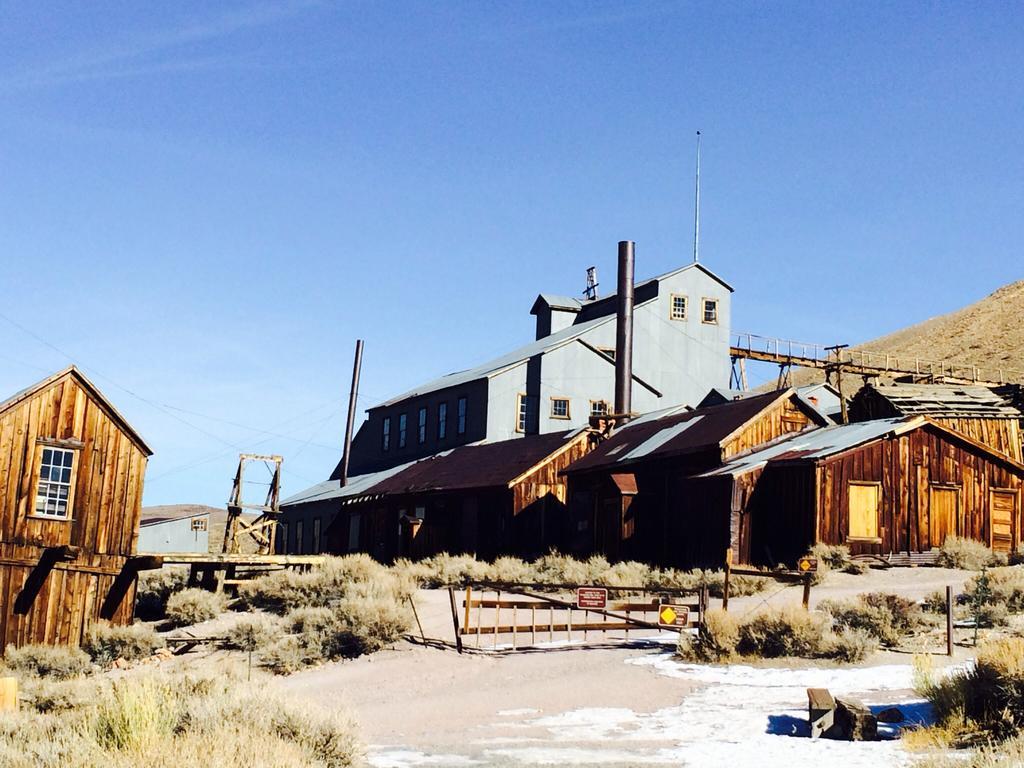Can you describe this image briefly? In this picture there are few wooden houses and there is a building behind it and the sky is in blue color. 